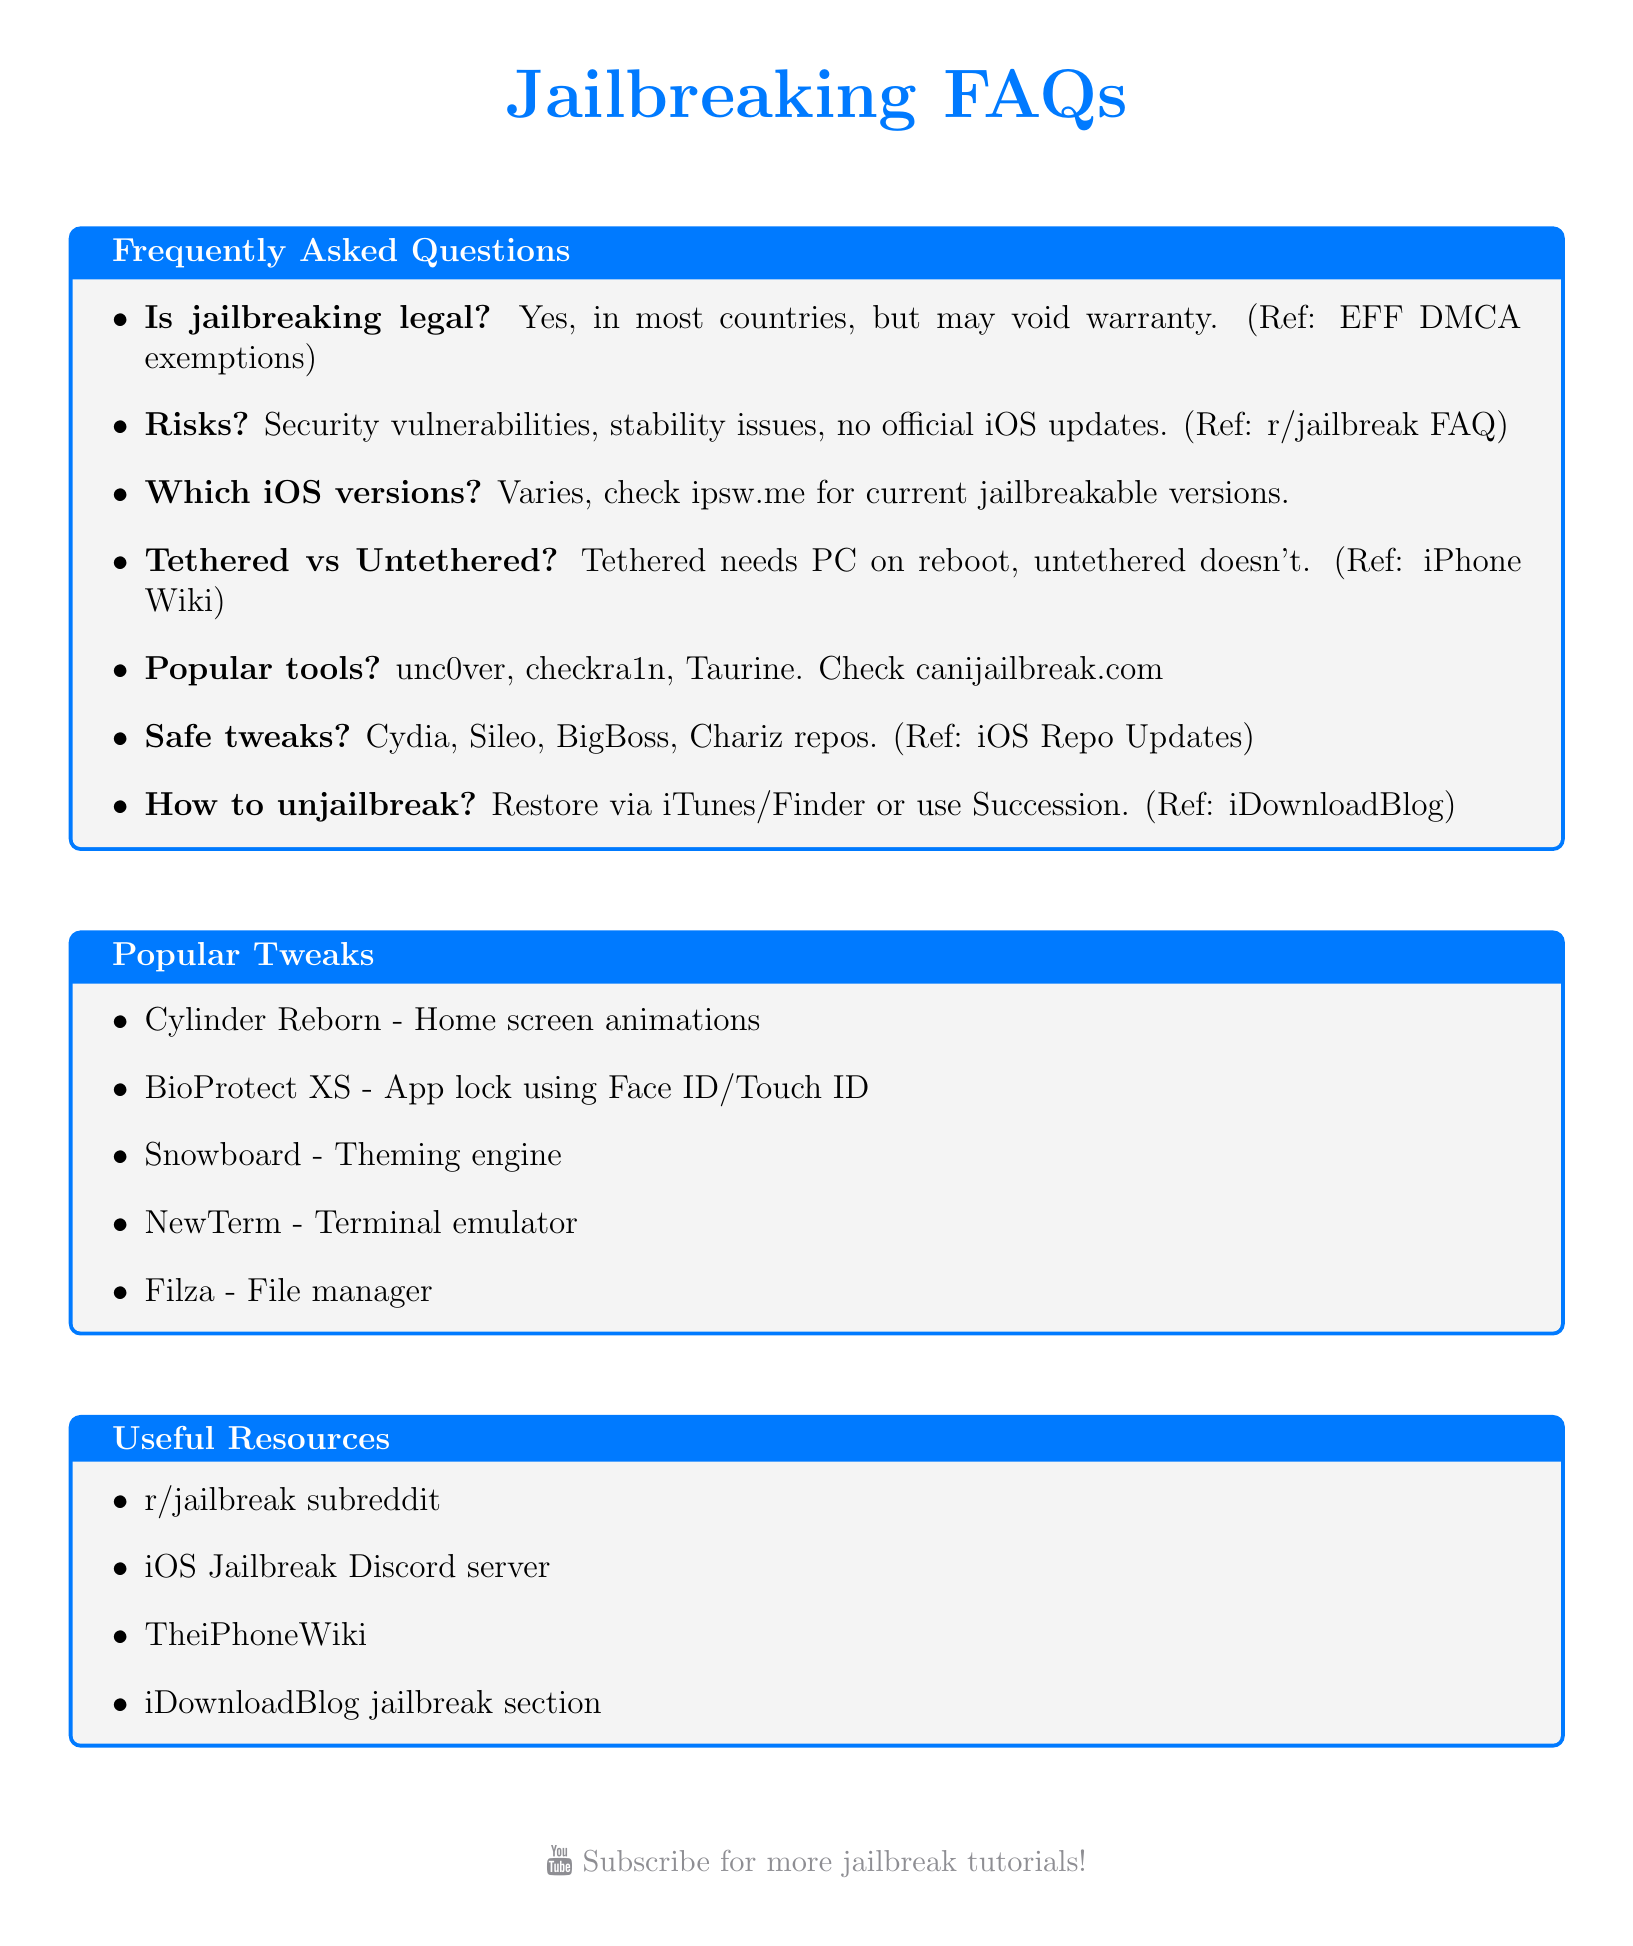Is jailbreaking legal? The document states that jailbreaking is legal in most countries, including the US.
Answer: Yes What are the risks of jailbreaking? The document lists potential security vulnerabilities and stability issues as risks of jailbreaking.
Answer: Security vulnerabilities, stability issues Which website can check current jailbreakable versions? The document mentions a specific website for checking jailbreakable versions.
Answer: ipsw.me What tool can be used to unjailbreak a device? The document suggests restoring the device using iTunes or Finder or using a specific tool.
Answer: Succession What is a popular tweak for home screen animations? The document lists a specific tweak related to home screen animations.
Answer: Cylinder Reborn What type of jailbreak requires a computer each reboot? The document explains the difference between tethered and untethered jailbreaks.
Answer: Tethered How many popular tweaks are listed in the document? The document provides a list of popular tweaks.
Answer: Five Where can I find safe tweaks? The document mentions specific sources where safe tweaks can be found.
Answer: Cydia, Sileo, BigBoss, Chariz Repos 